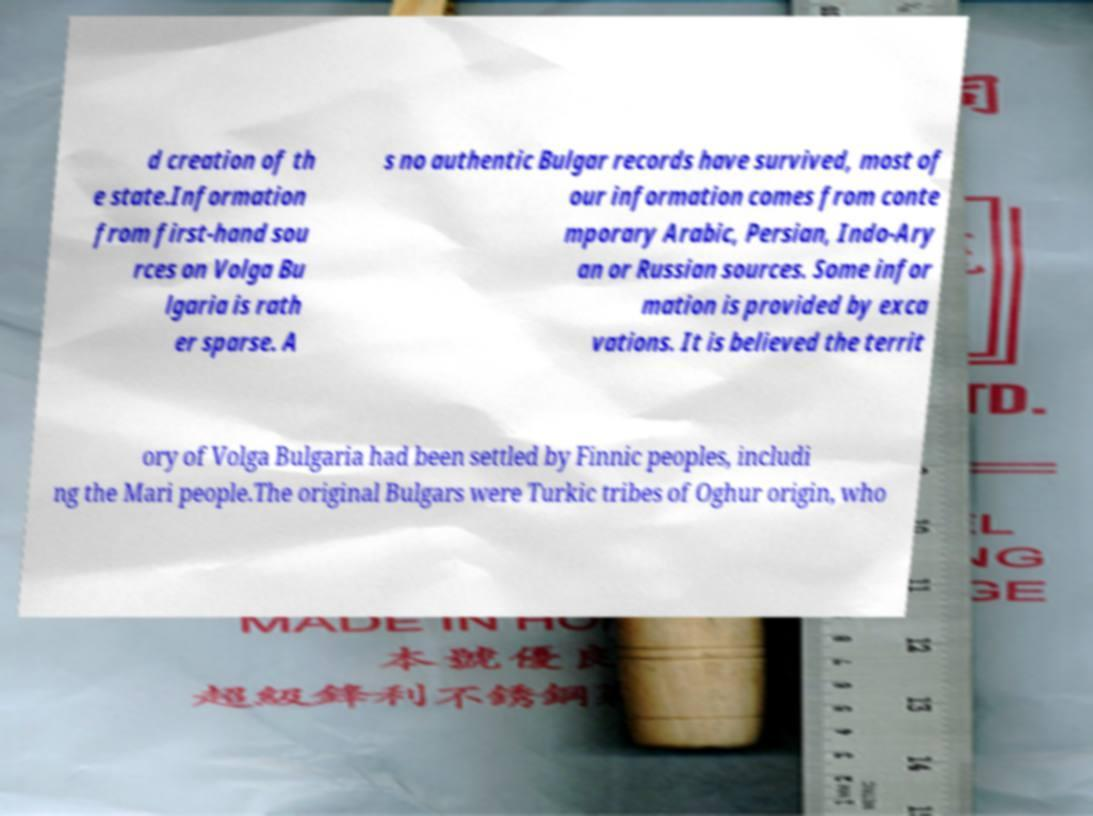I need the written content from this picture converted into text. Can you do that? d creation of th e state.Information from first-hand sou rces on Volga Bu lgaria is rath er sparse. A s no authentic Bulgar records have survived, most of our information comes from conte mporary Arabic, Persian, Indo-Ary an or Russian sources. Some infor mation is provided by exca vations. It is believed the territ ory of Volga Bulgaria had been settled by Finnic peoples, includi ng the Mari people.The original Bulgars were Turkic tribes of Oghur origin, who 